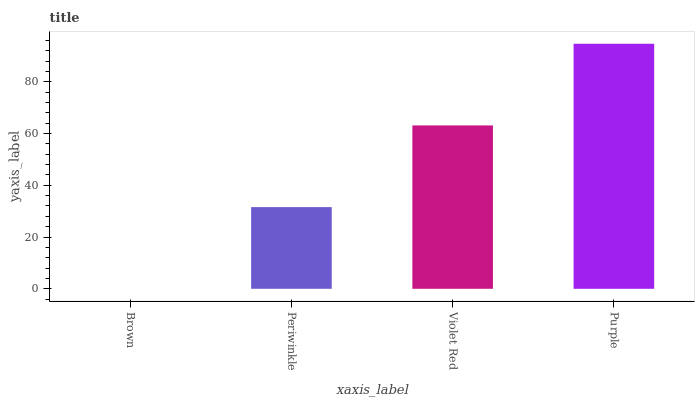Is Brown the minimum?
Answer yes or no. Yes. Is Purple the maximum?
Answer yes or no. Yes. Is Periwinkle the minimum?
Answer yes or no. No. Is Periwinkle the maximum?
Answer yes or no. No. Is Periwinkle greater than Brown?
Answer yes or no. Yes. Is Brown less than Periwinkle?
Answer yes or no. Yes. Is Brown greater than Periwinkle?
Answer yes or no. No. Is Periwinkle less than Brown?
Answer yes or no. No. Is Violet Red the high median?
Answer yes or no. Yes. Is Periwinkle the low median?
Answer yes or no. Yes. Is Periwinkle the high median?
Answer yes or no. No. Is Brown the low median?
Answer yes or no. No. 